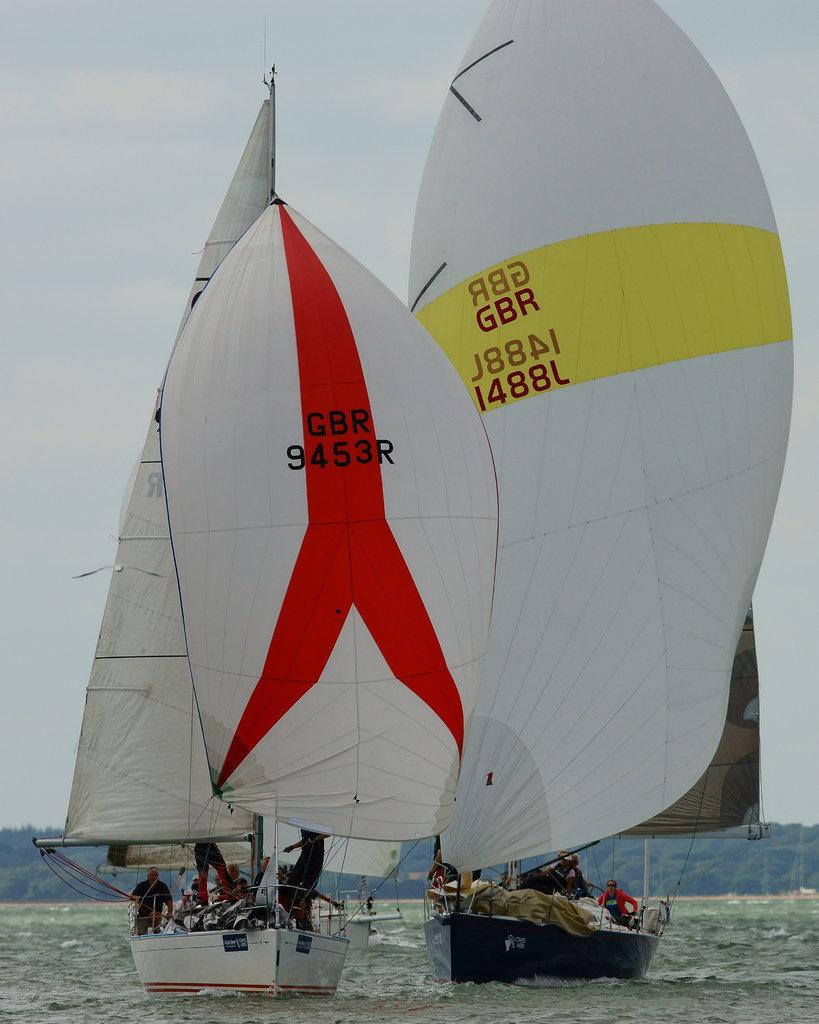What is happening on the water in the image? There are boats on the water in the image. Are there any people in the boats? Yes, there are people in the boats. What can be seen in the background of the image? There are trees visible in the background of the image. Can you hear the people in the boats laughing in the image? There is no sound present in the image, so it is not possible to hear the people laughing. What shape is the water in the image? The shape of the water cannot be determined from the image alone, as it is a two-dimensional representation. 